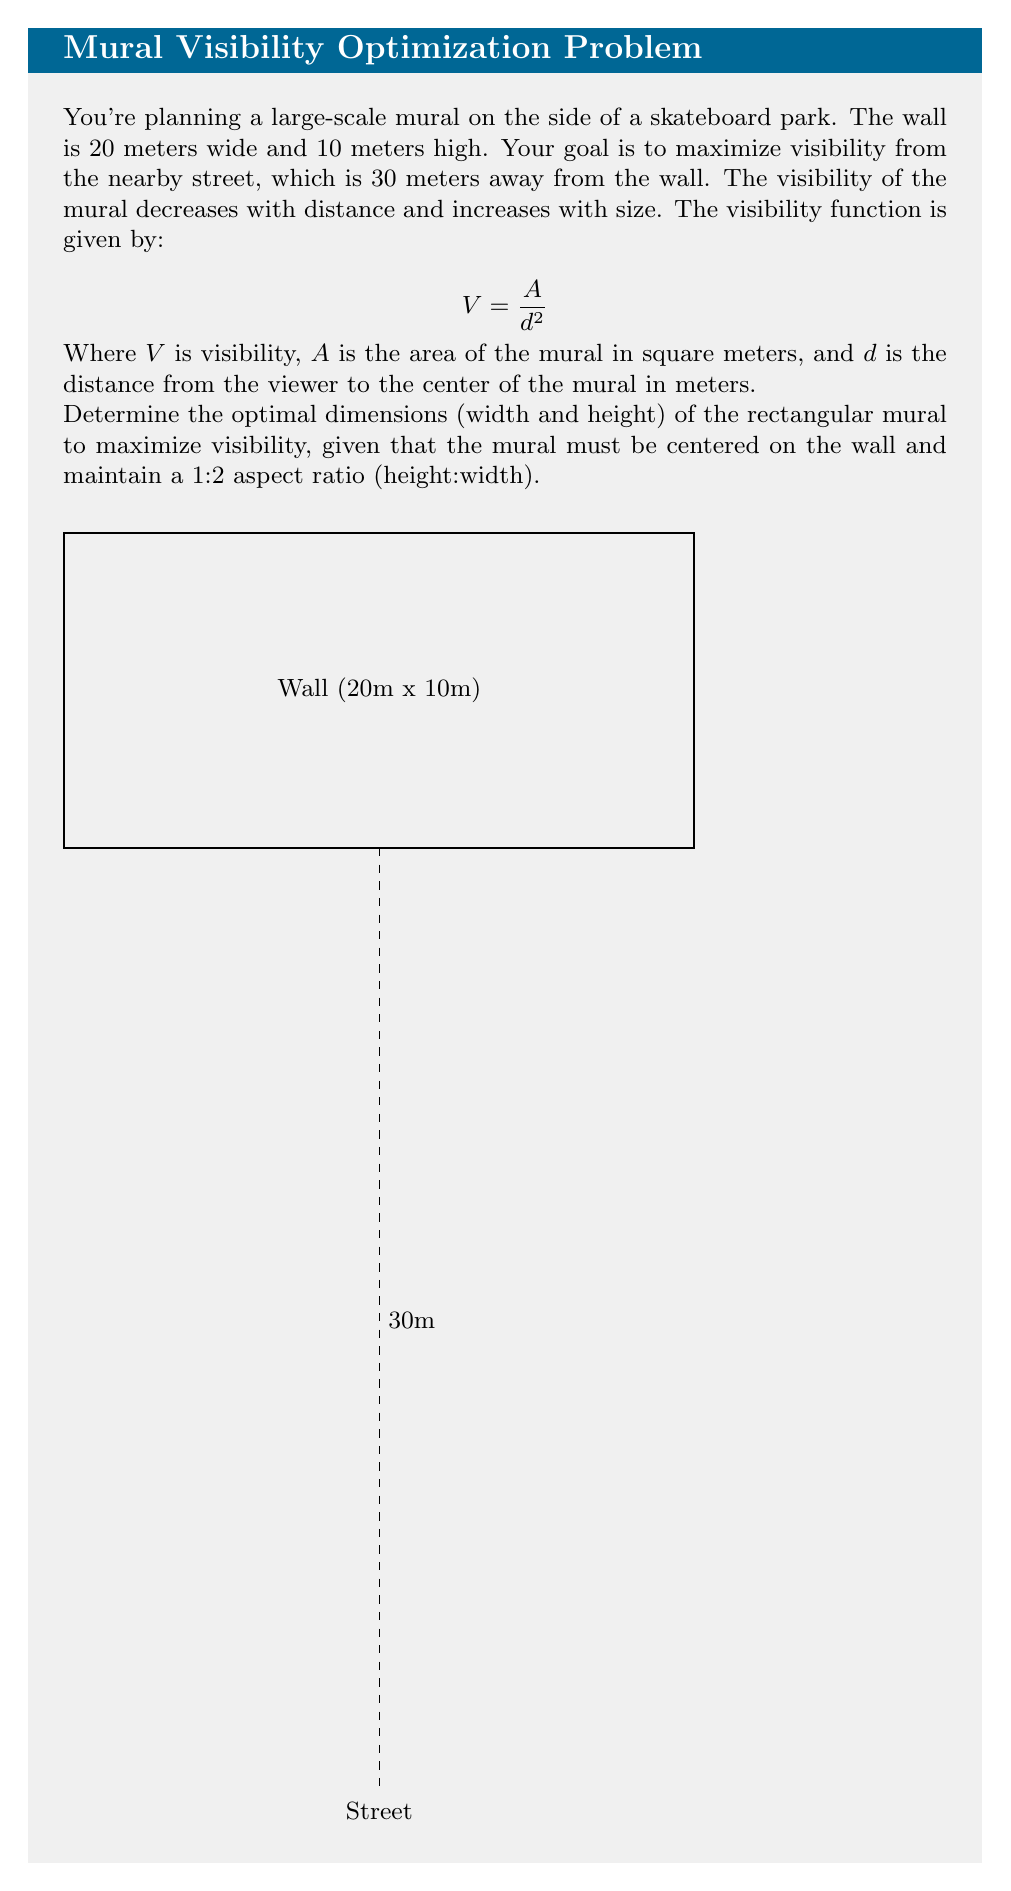What is the answer to this math problem? Let's approach this step-by-step:

1) Let the width of the mural be $w$ and the height be $h$. Given the 1:2 aspect ratio, we can express $h$ in terms of $w$:

   $h = \frac{w}{2}$

2) The area of the mural is:

   $A = w \cdot h = w \cdot \frac{w}{2} = \frac{w^2}{2}$

3) The distance $d$ from the viewer to the center of the mural is constant:

   $d = 30 + 5 = 35$ meters (30m to the wall + 5m to the center of the wall)

4) Substituting into the visibility function:

   $$V = \frac{A}{d^2} = \frac{w^2/2}{35^2} = \frac{w^2}{2450}$$

5) To find the maximum value of $V$, we need to find the largest possible $w$. Given that the mural must fit on the wall:

   $w \leq 20$ (width constraint)
   $h = \frac{w}{2} \leq 10$ (height constraint)

   The height constraint gives us: $w \leq 20$

6) Therefore, the maximum width is 20m, and the corresponding height is 10m.

7) The optimal dimensions are: width = 20m, height = 10m

8) The maximum visibility is:

   $$V_{max} = \frac{20^2}{2450} = \frac{400}{2450} \approx 0.1633$$
Answer: 20m x 10m 